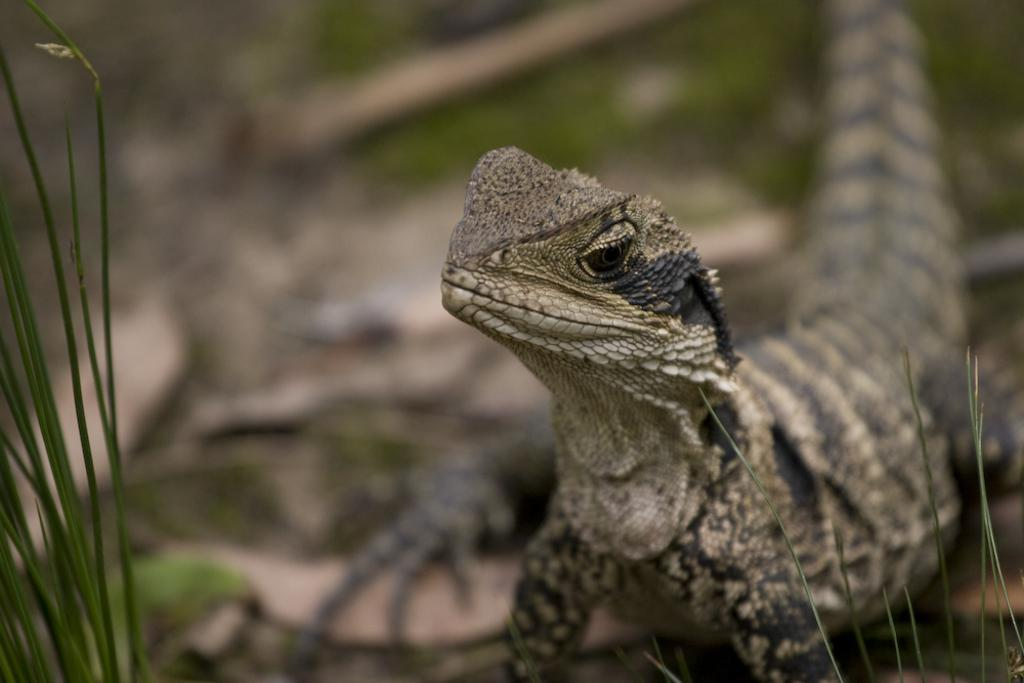What type of animal can be seen in the image? There is a reptile in the image. What can be seen on the left side of the image? There are leaves visible on the left side of the image. How would you describe the background of the image? The background of the image is blurred. What type of marble is being used to cover the reptile in the image? There is no marble or covering present in the image; it features a reptile and leaves. Can you tell me how many porters are assisting the reptile in the image? There are no porters present in the image; it features a reptile and leaves. 